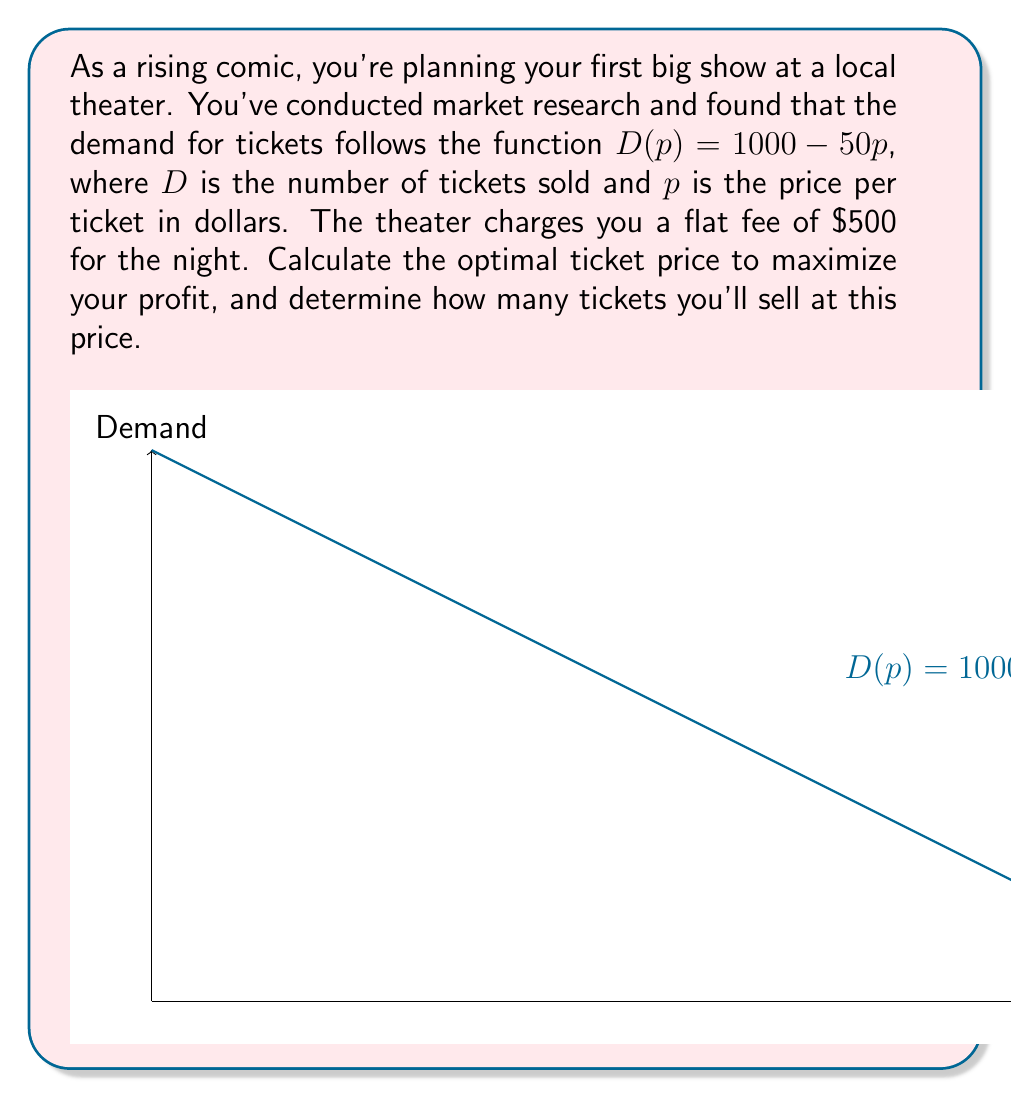Could you help me with this problem? Let's approach this step-by-step:

1) First, we need to set up the profit function. Profit is revenue minus cost:
   $$ \text{Profit} = \text{Revenue} - \text{Cost} $$

2) Revenue is price times quantity:
   $$ \text{Revenue} = p \cdot D(p) = p(1000 - 50p) = 1000p - 50p^2 $$

3) Cost is the flat fee of $500, so our profit function is:
   $$ \text{Profit} = 1000p - 50p^2 - 500 $$

4) To maximize profit, we find where the derivative of the profit function equals zero:
   $$ \frac{d}{dp}(\text{Profit}) = 1000 - 100p = 0 $$

5) Solving this equation:
   $$ 1000 - 100p = 0 $$
   $$ -100p = -1000 $$
   $$ p = 10 $$

6) The second derivative is negative ($-100$), confirming this is a maximum.

7) To find the number of tickets sold at this price, we plug $p = 10$ into our demand function:
   $$ D(10) = 1000 - 50(10) = 500 $$

Therefore, the optimal ticket price is $10, and you'll sell 500 tickets at this price.
Answer: $10 per ticket; 500 tickets sold 